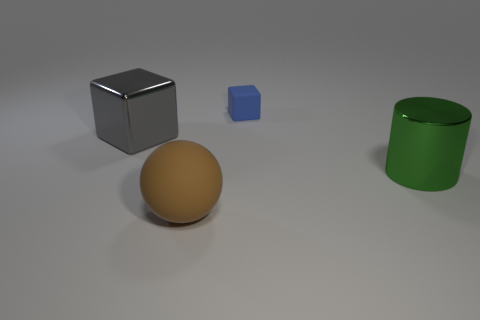What number of blocks have the same material as the big green cylinder?
Keep it short and to the point. 1. Is the number of brown matte things that are behind the tiny rubber block less than the number of blue things on the left side of the large green metal cylinder?
Make the answer very short. Yes. What material is the big thing that is in front of the large thing that is on the right side of the matte object on the left side of the blue block made of?
Your response must be concise. Rubber. What size is the object that is to the left of the tiny blue object and in front of the big block?
Your response must be concise. Large. What number of spheres are large green shiny things or brown objects?
Ensure brevity in your answer.  1. The metal cube that is the same size as the brown ball is what color?
Ensure brevity in your answer.  Gray. Is there any other thing that has the same shape as the brown matte thing?
Offer a very short reply. No. The other rubber object that is the same shape as the big gray thing is what color?
Offer a very short reply. Blue. How many things are brown matte balls or objects on the right side of the gray thing?
Keep it short and to the point. 3. Are there fewer objects that are in front of the metallic block than large matte objects?
Your response must be concise. No. 